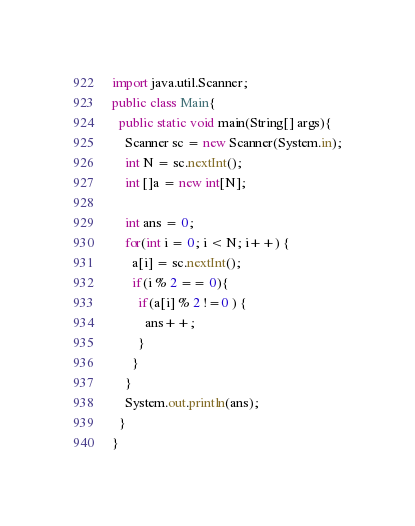Convert code to text. <code><loc_0><loc_0><loc_500><loc_500><_Java_>import java.util.Scanner;
public class Main{
  public static void main(String[] args){
    Scanner sc = new Scanner(System.in);
    int N = sc.nextInt();
    int []a = new int[N];
    
    int ans = 0;
    for(int i = 0; i < N; i++) {
      a[i] = sc.nextInt();
      if(i % 2 == 0){
        if(a[i] % 2 !=0 ) {
          ans++;
        }
      }
    }
    System.out.println(ans);
  }
}</code> 